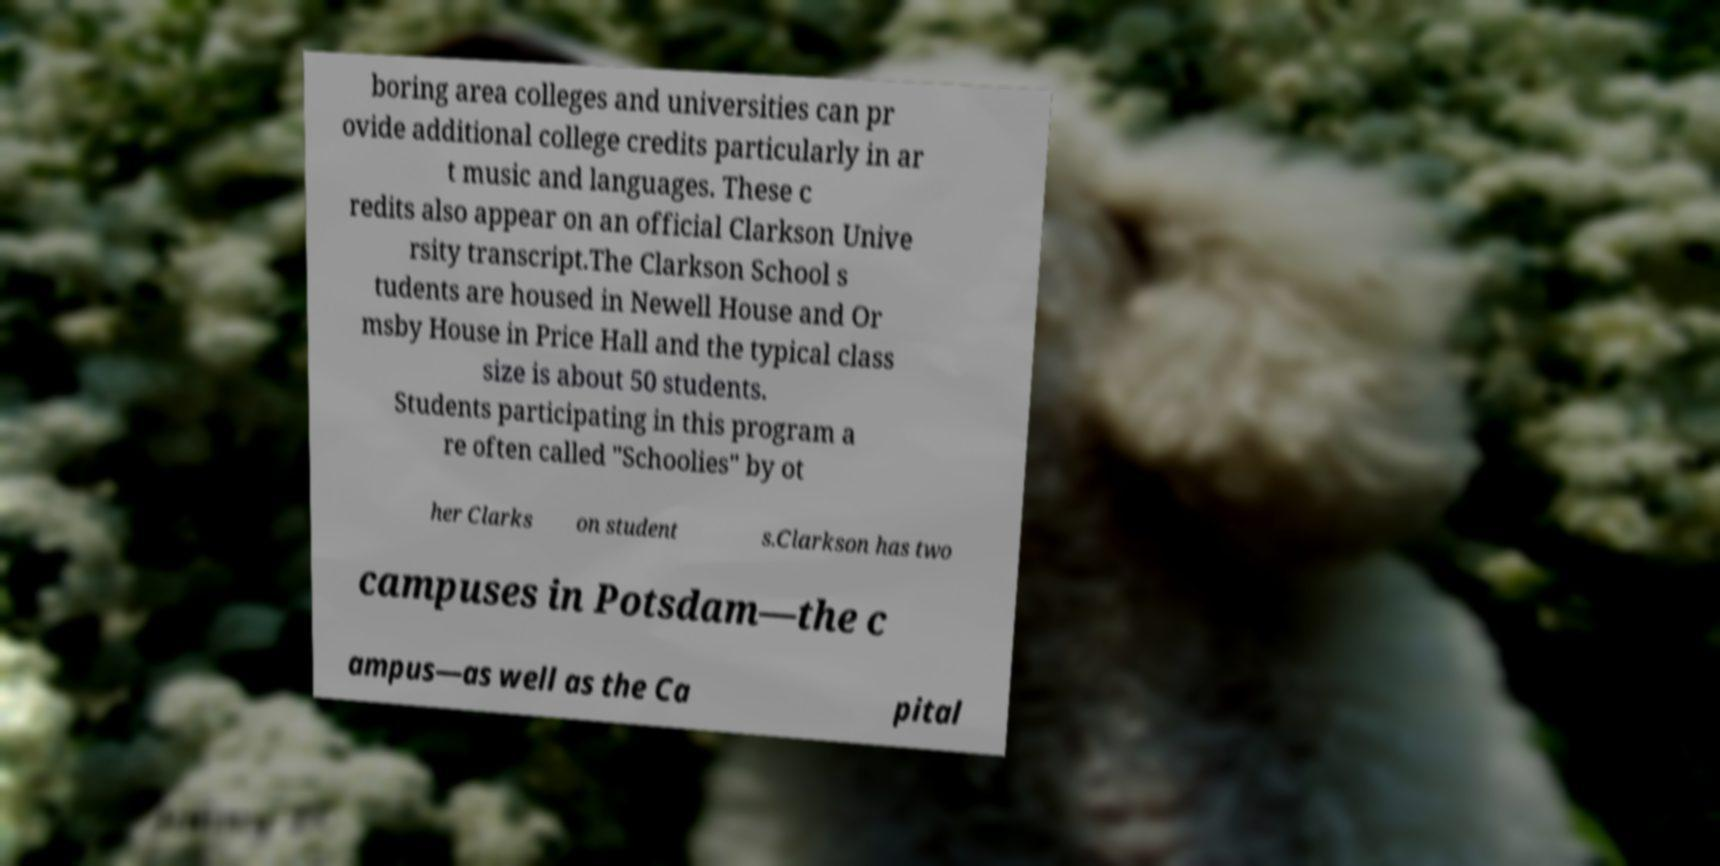Could you assist in decoding the text presented in this image and type it out clearly? boring area colleges and universities can pr ovide additional college credits particularly in ar t music and languages. These c redits also appear on an official Clarkson Unive rsity transcript.The Clarkson School s tudents are housed in Newell House and Or msby House in Price Hall and the typical class size is about 50 students. Students participating in this program a re often called "Schoolies" by ot her Clarks on student s.Clarkson has two campuses in Potsdam—the c ampus—as well as the Ca pital 